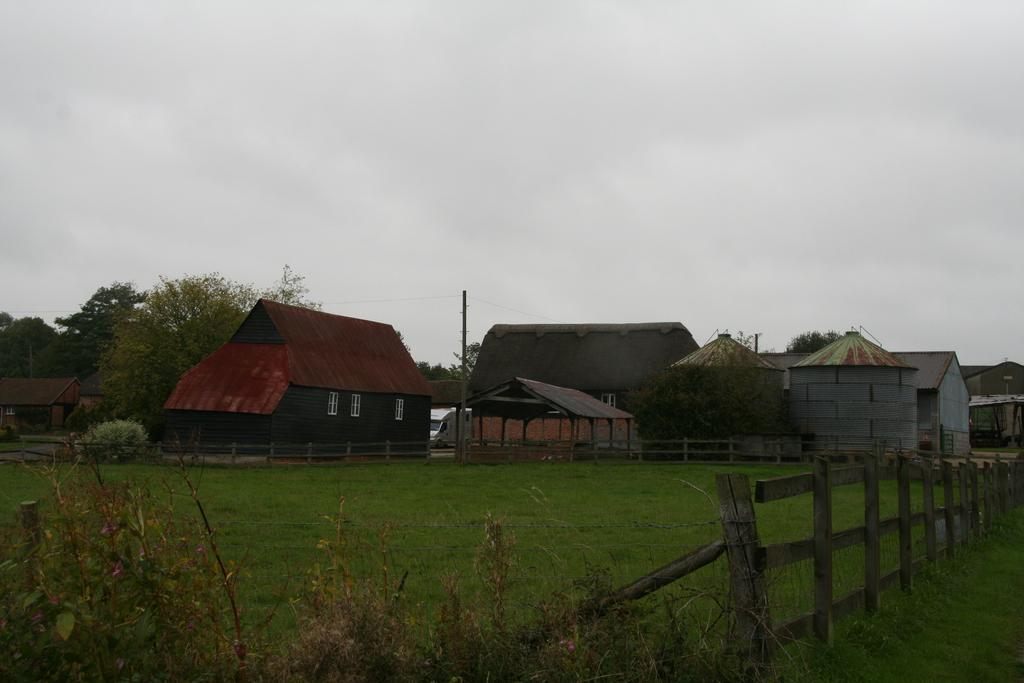What type of structures are present in the image? There are houses in the image. What is the purpose of the fence in the image? The fence serves as a boundary or barrier in the image. What can be seen in the middle of the image? A pole is visible in the middle of the image. What is visible at the top of the image? The sky is visible at the top of the image. What type of brake is installed on the pole in the image? There is no brake present in the image; it only features a pole, houses, a fence, and the sky. What news headline is displayed on the houses in the image? There are no news headlines visible on the houses in the image. 